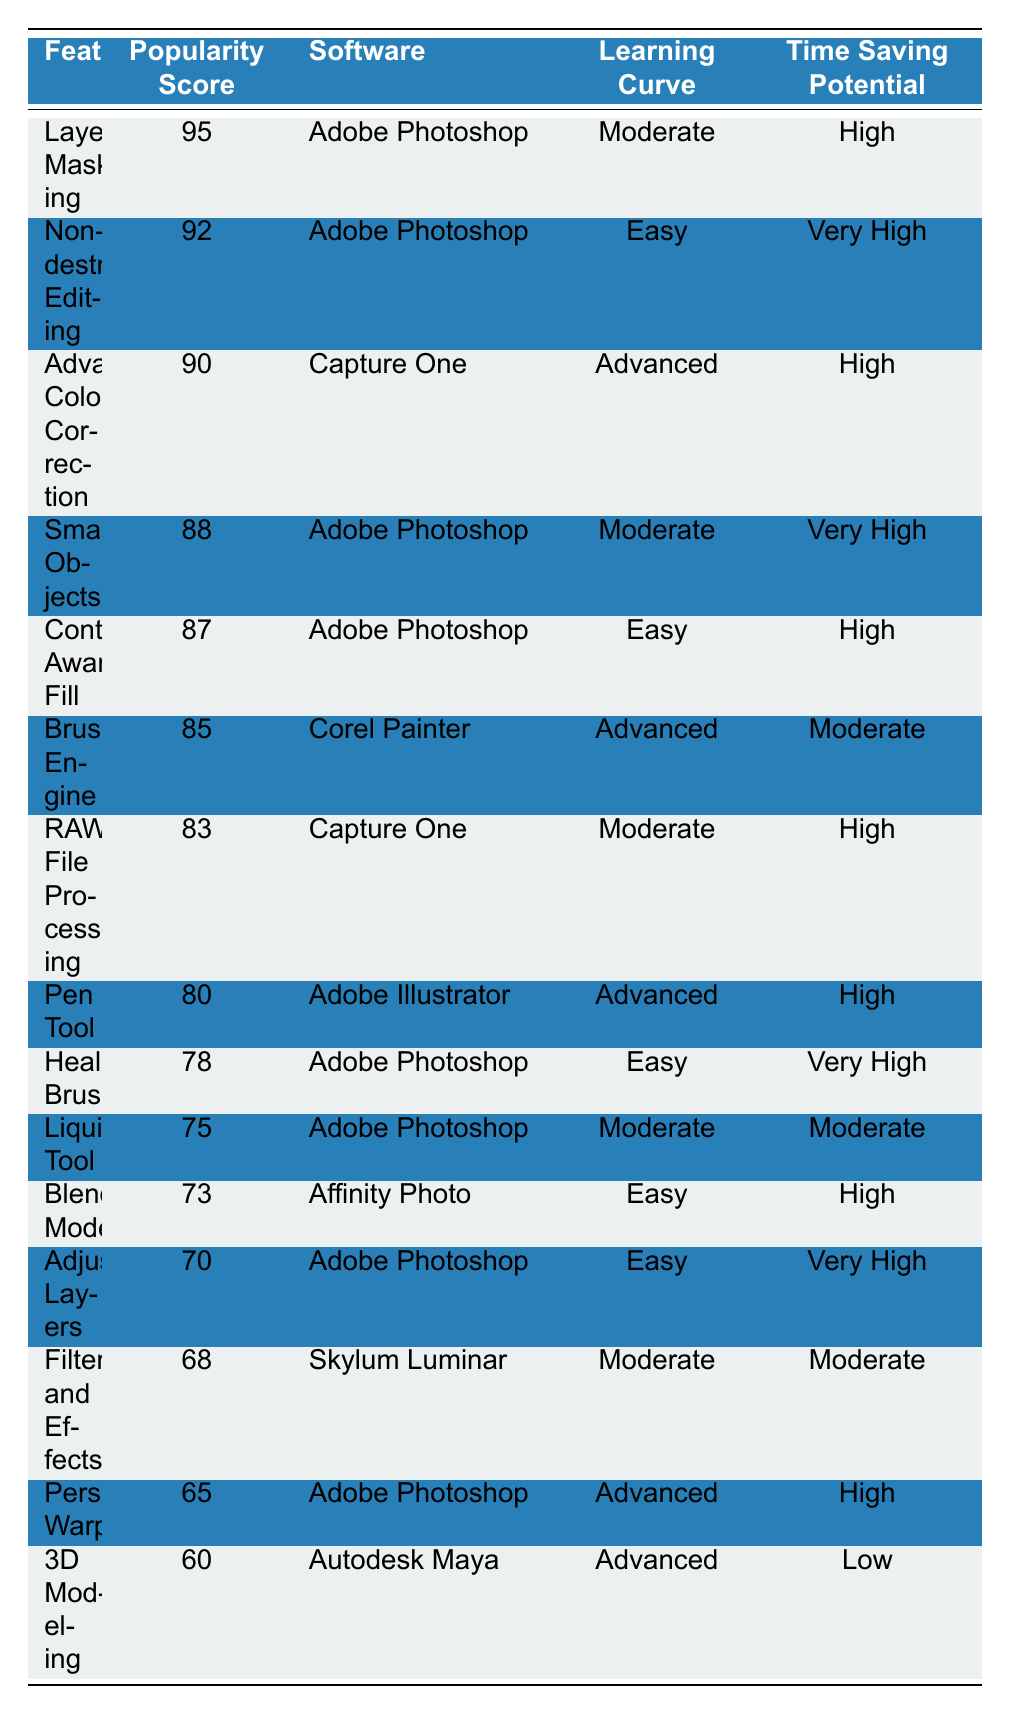What is the most popular feature among professional designers? The feature with the highest popularity score is "Layer Masking," which has a score of 95.
Answer: Layer Masking Which software has the highest number of features listed? By counting the occurrences in the software column, "Adobe Photoshop" appears 7 times, which is more than any other software.
Answer: Adobe Photoshop What is the learning curve for "Advanced Color Correction"? The learning curve for "Advanced Color Correction" is categorized as "Advanced."
Answer: Advanced How many features have a popularity score above 85? The features with a popularity score above 85 are "Layer Masking," "Non-destructive Editing," "Advanced Color Correction," "Smart Objects," "Content-Aware Fill," "Brush Engine," "Healing Brush," and "Adjustment Layers," totaling 7 features.
Answer: 7 Is "3D Modeling" considered easy to learn? No, "3D Modeling" has an advanced learning curve, which indicates it's not easy to learn.
Answer: No What is the average popularity score of features associated with "Adobe Photoshop"? The scores for the features associated with "Adobe Photoshop" are 95, 92, 88, 87, 78, 75, 70, which sum to 605. There are 7 features, so the average is 605 / 7 = 86.43.
Answer: 86.43 Which feature has the lowest time-saving potential? "3D Modeling" has the lowest time-saving potential categorized as "Low."
Answer: Low How many features have a "Very High" time-saving potential? The features with "Very High" time-saving potential are "Non-destructive Editing," "Smart Objects," "Healing Brush," "Adjustment Layers," and "Filters and Effects," totaling 5 features.
Answer: 5 What is the only feature with a popularity score of 60? The only feature with a popularity score of 60 is "3D Modeling."
Answer: 3D Modeling Which feature is the easiest to learn based on the learning curve? "Non-destructive Editing," "Content-Aware Fill," "Healing Brush," "Blending Modes," and "Adjustment Layers" are labeled as "Easy," with "Non-destructive Editing" being the first listed in the table.
Answer: Non-destructive Editing 